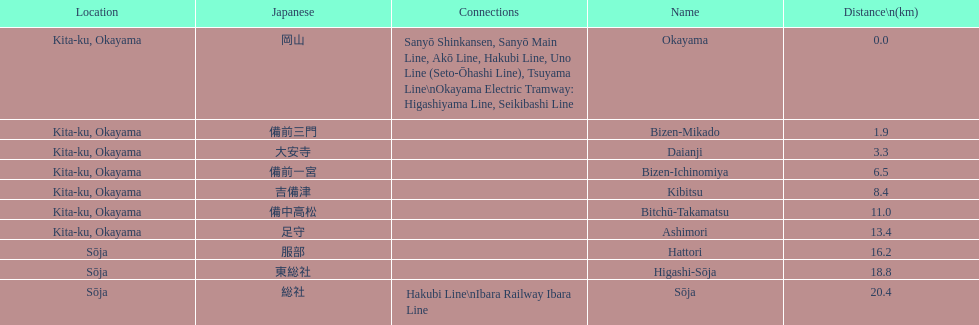How many station are located in kita-ku, okayama? 7. 